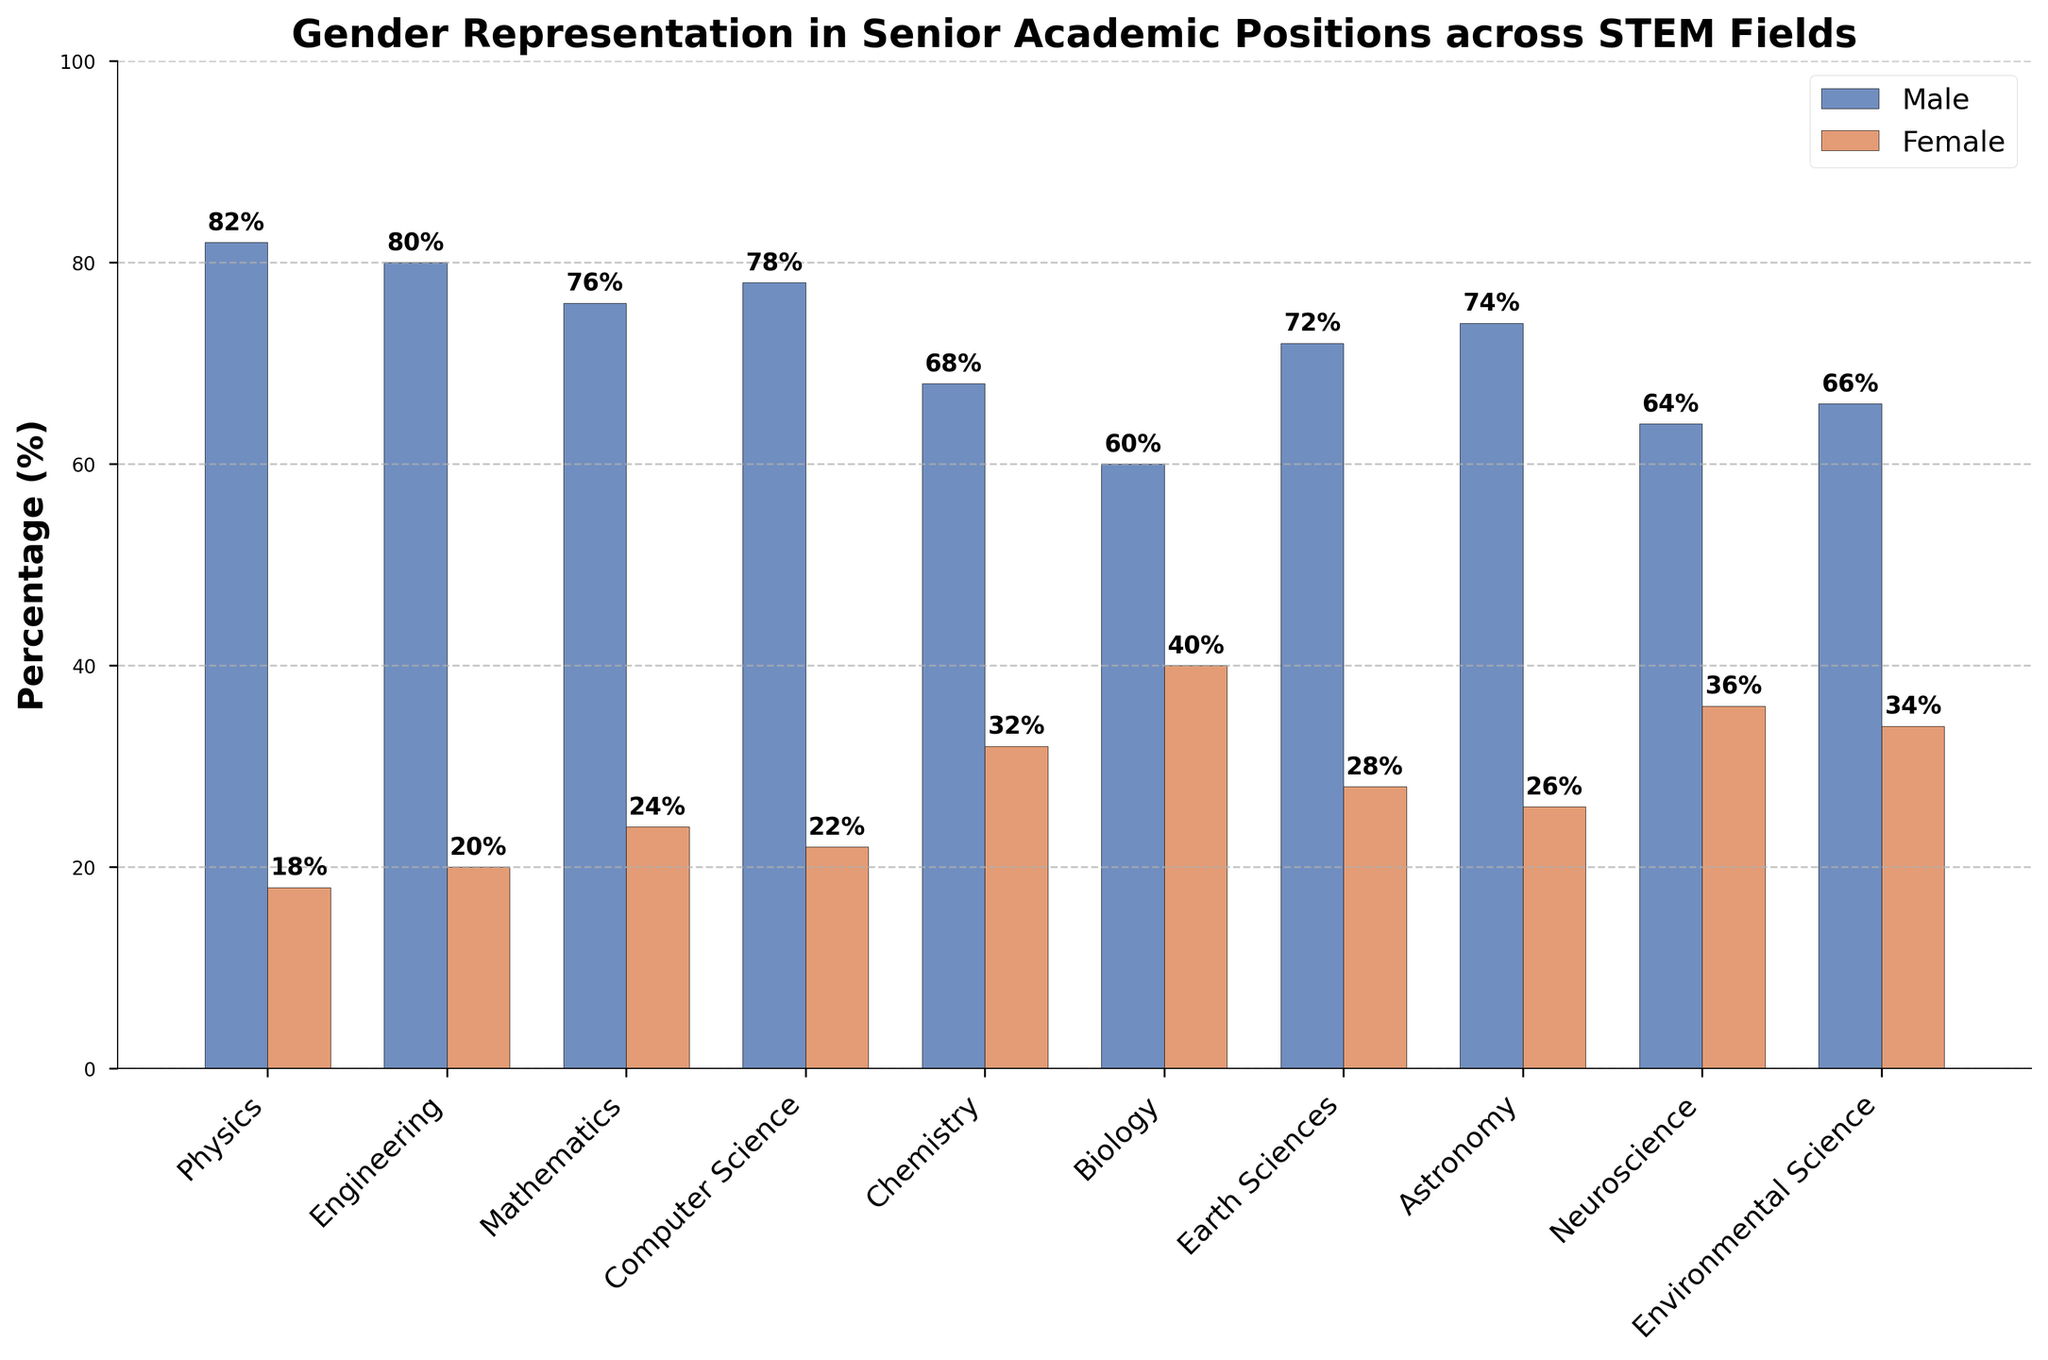Which field has the highest percentage of female representation? By visually inspecting the height of the red bars representing female percentages, Biology has the highest female percentage with a bar reaching 40%.
Answer: Biology What is the difference in female representation between Physics and Chemistry? The female percentage in Physics is 18% and in Chemistry is 32%. Subtract 18 from 32 to get the difference, which is 32 - 18 = 14.
Answer: 14 Identify fields where female representation is less than 25%. By comparing the heights of the red bars corresponding to female representation, fields with less than 25% female representation are Physics (18%), Engineering (20%), Computer Science (22%), and Mathematics (24%).
Answer: Physics, Engineering, Computer Science, Mathematics Which field has the smallest gender gap? The gender gap can be determined by the difference between male and female percentages. The smallest gap is observed in Biology, where male is 60% and female is 40%, leading to a gap of 60 - 40 = 20.
Answer: Biology In how many fields does male representation exceed 75%? By observing the heights of the blue bars representing male percentages, fields exceeding 75% male representation are Physics (82%), Engineering (80%), Mathematics (76%), and Computer Science (78%). This results in 4 fields.
Answer: 4 What is the average percentage of female representation across all fields? Sum the female percentages: 18 + 20 + 24 + 22 + 32 + 40 + 28 + 26 + 36 + 34 = 280. Divide by the number of fields, which is 10. So, the average is 280/10 = 28.
Answer: 28 Compare the gender representation in Earth Sciences and Astronomy and state which has a larger female percentage. Earth Sciences has female representation of 28%, while Astronomy has 26%. Comparatively, Earth Sciences have a larger female percentage.
Answer: Earth Sciences In which fields do women constitute more than 30% but less than 40% of senior academic positions? Fields with female percentages between 30% and 40% are Chemistry (32%), Neuroscience (36%), and Environmental Science (34%).
Answer: Chemistry, Neuroscience, Environmental Science Is there any field where the percentages of male and female representation sum up to exactly 100? By inspecting the bars's height and summing male and female percentages for each field, all fields naturally sum up to 100%.
Answer: All fields 